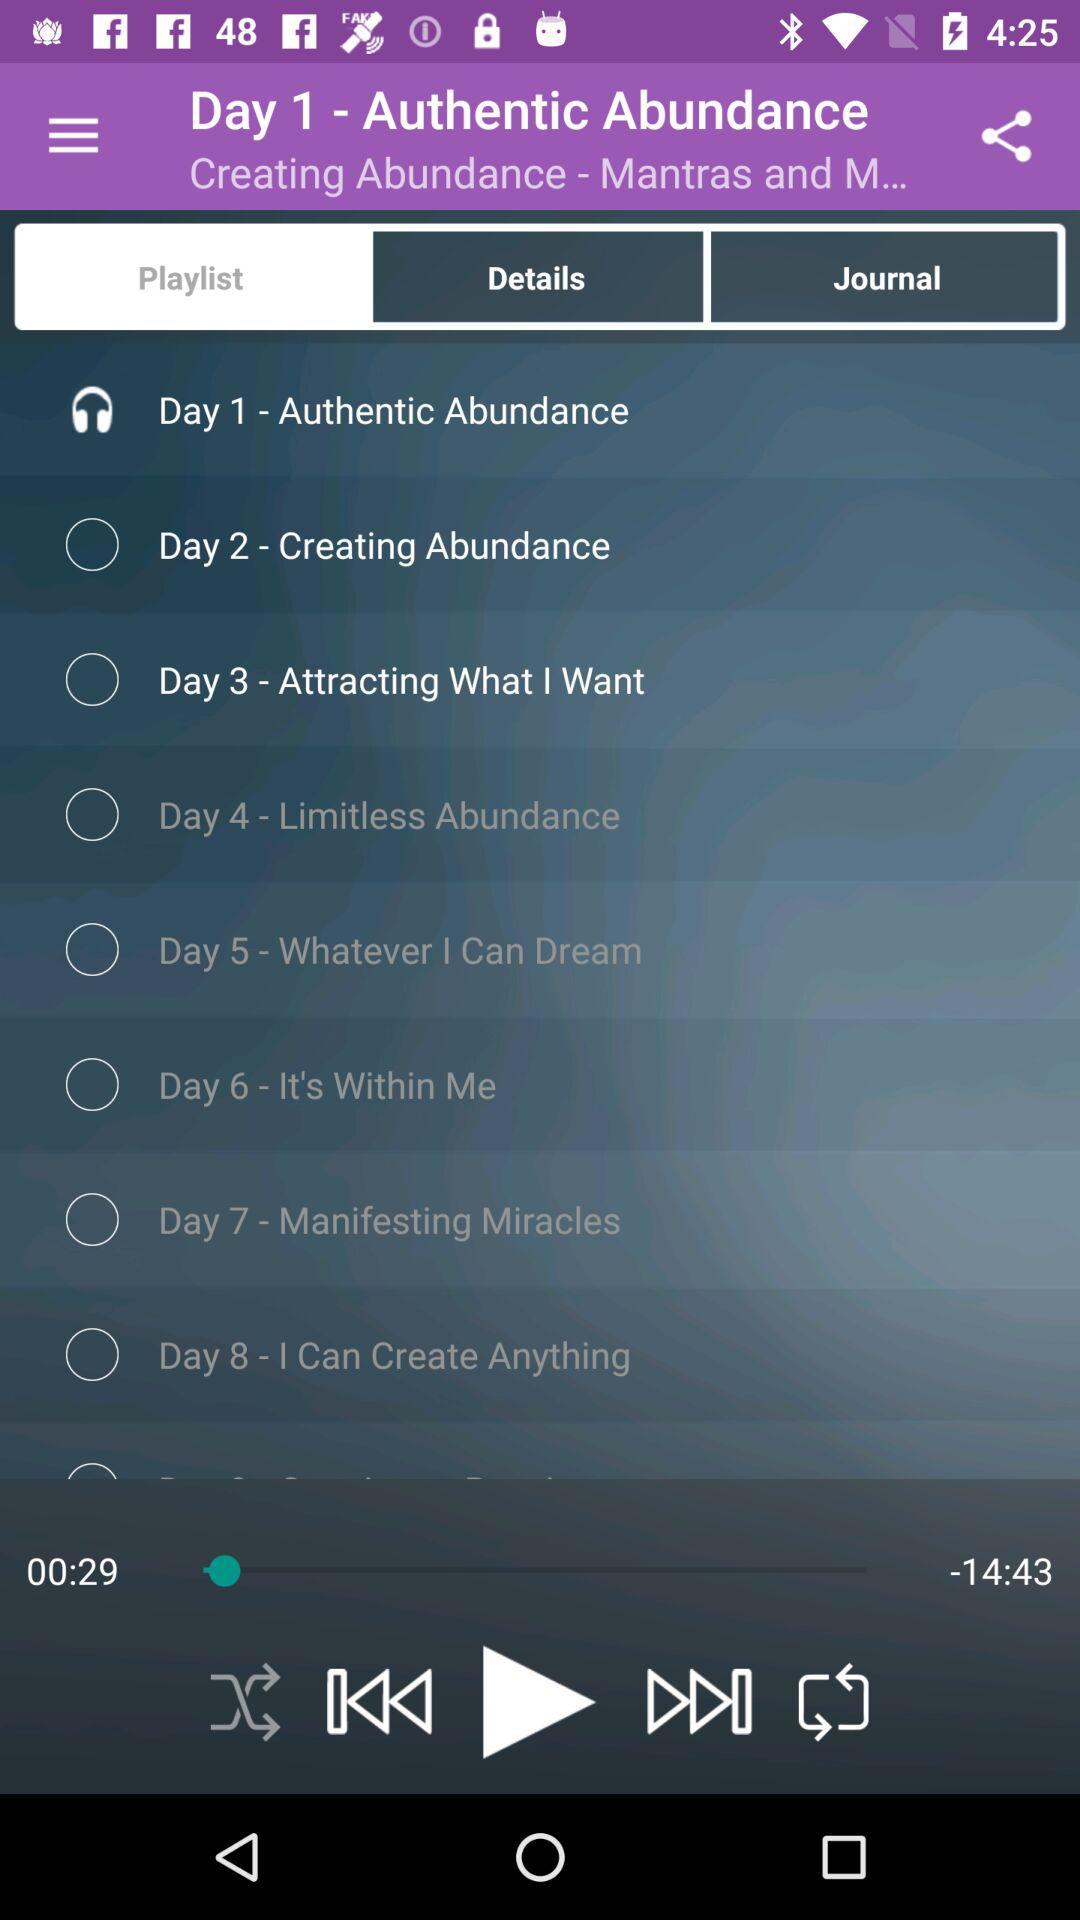Which song will play on Day 8? The song that will play on Day 8 is "I Can Create Anything". 